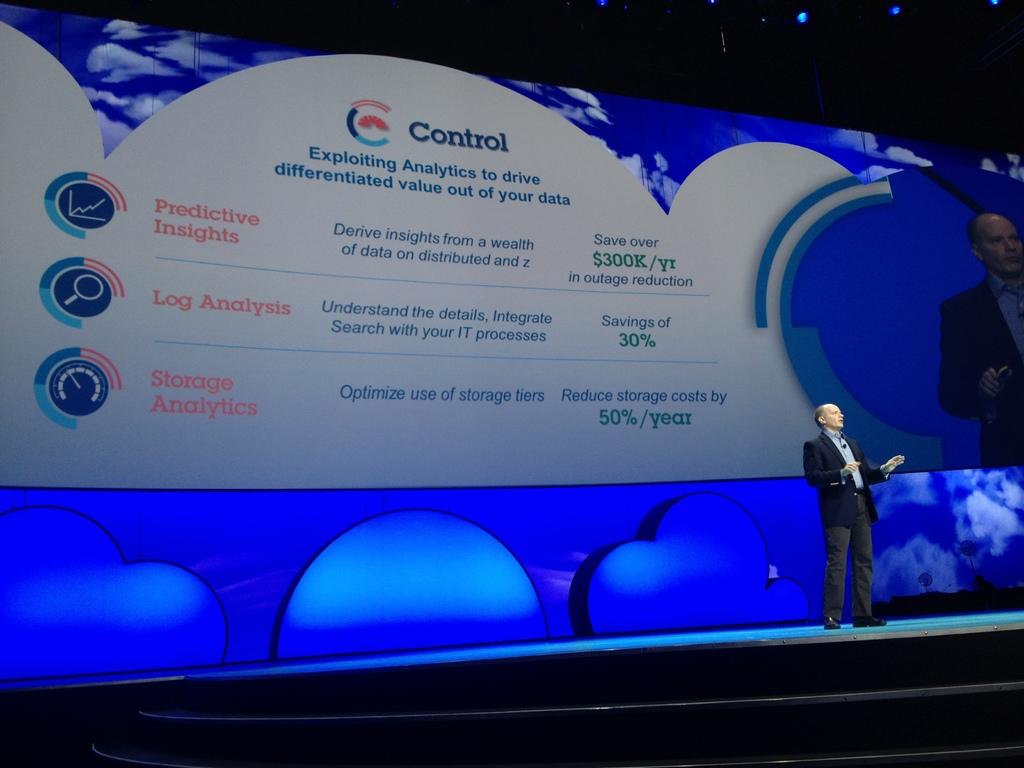What percentage is savings of?
Offer a very short reply. 30%. By how much can you reduce storage costs?
Your answer should be very brief. 50%. 